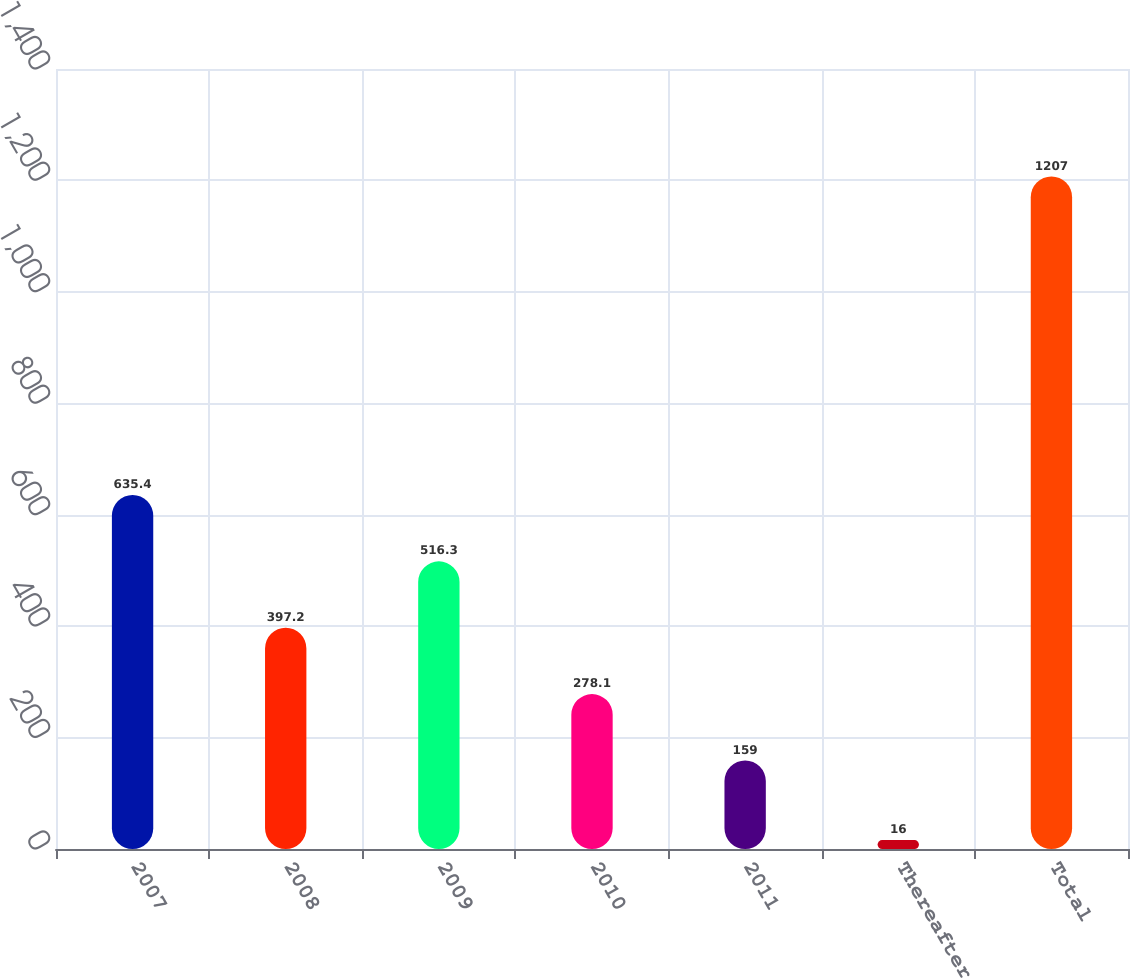Convert chart to OTSL. <chart><loc_0><loc_0><loc_500><loc_500><bar_chart><fcel>2007<fcel>2008<fcel>2009<fcel>2010<fcel>2011<fcel>Thereafter<fcel>Total<nl><fcel>635.4<fcel>397.2<fcel>516.3<fcel>278.1<fcel>159<fcel>16<fcel>1207<nl></chart> 